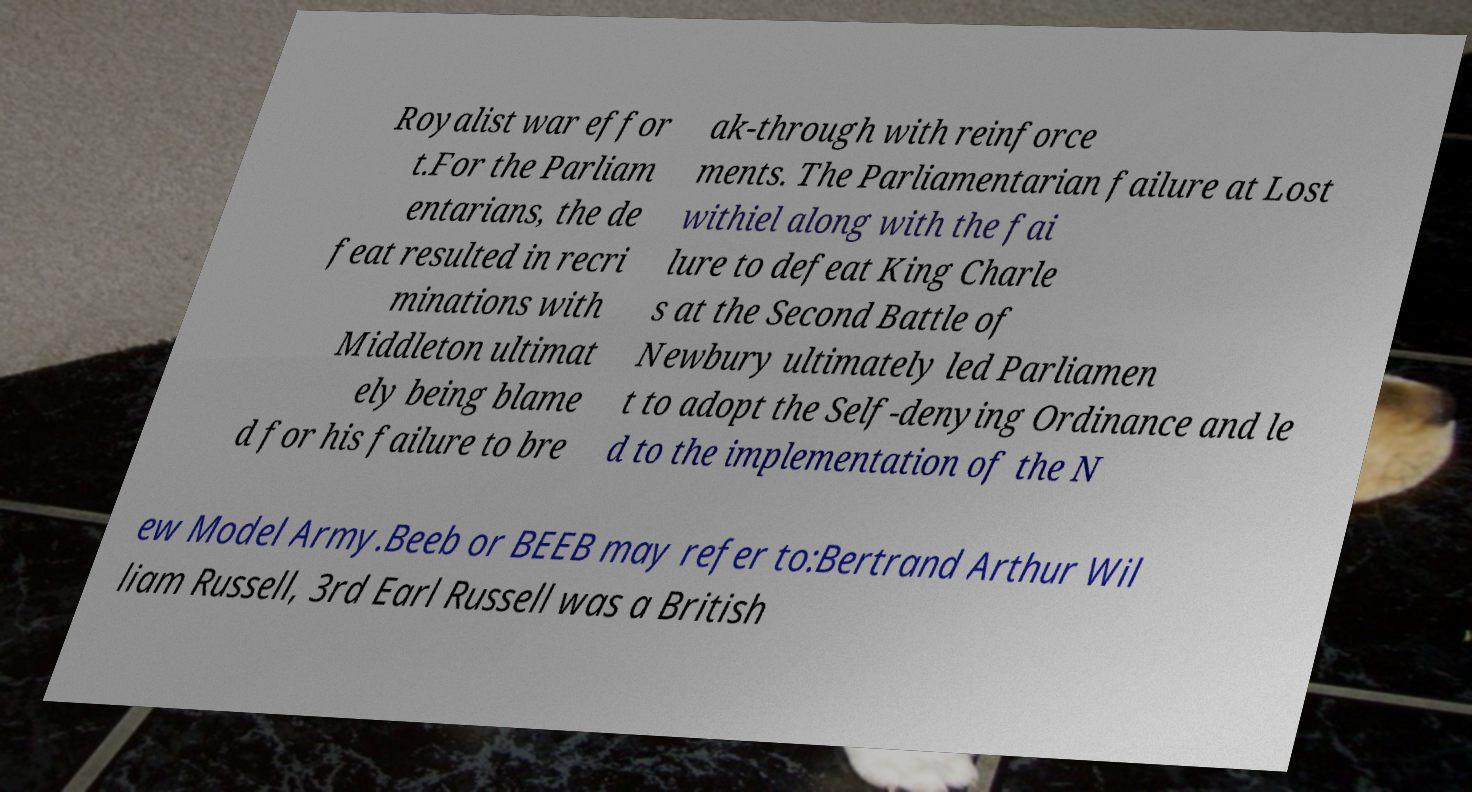Can you read and provide the text displayed in the image?This photo seems to have some interesting text. Can you extract and type it out for me? Royalist war effor t.For the Parliam entarians, the de feat resulted in recri minations with Middleton ultimat ely being blame d for his failure to bre ak-through with reinforce ments. The Parliamentarian failure at Lost withiel along with the fai lure to defeat King Charle s at the Second Battle of Newbury ultimately led Parliamen t to adopt the Self-denying Ordinance and le d to the implementation of the N ew Model Army.Beeb or BEEB may refer to:Bertrand Arthur Wil liam Russell, 3rd Earl Russell was a British 